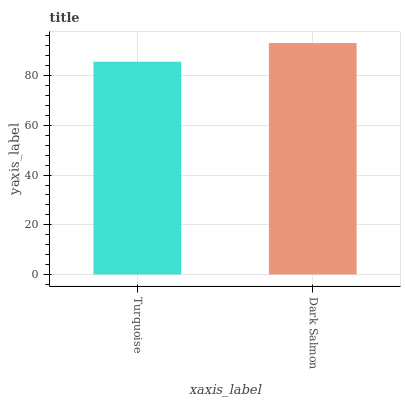Is Turquoise the minimum?
Answer yes or no. Yes. Is Dark Salmon the maximum?
Answer yes or no. Yes. Is Dark Salmon the minimum?
Answer yes or no. No. Is Dark Salmon greater than Turquoise?
Answer yes or no. Yes. Is Turquoise less than Dark Salmon?
Answer yes or no. Yes. Is Turquoise greater than Dark Salmon?
Answer yes or no. No. Is Dark Salmon less than Turquoise?
Answer yes or no. No. Is Dark Salmon the high median?
Answer yes or no. Yes. Is Turquoise the low median?
Answer yes or no. Yes. Is Turquoise the high median?
Answer yes or no. No. Is Dark Salmon the low median?
Answer yes or no. No. 